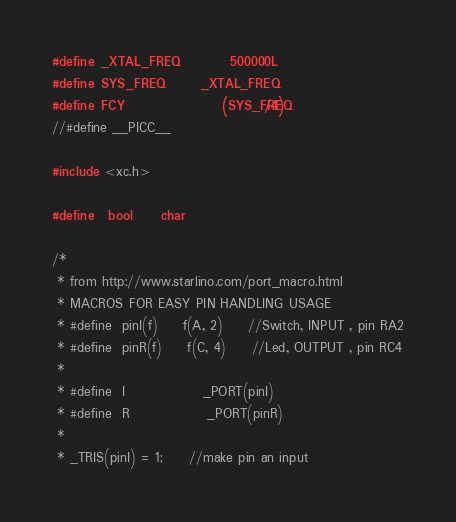<code> <loc_0><loc_0><loc_500><loc_500><_C_>#define _XTAL_FREQ		500000L
#define SYS_FREQ		_XTAL_FREQ
#define FCY				(SYS_FREQ/4)
//#define __PICC__

#include <xc.h>

#define	bool	char

/*
 * from http://www.starlino.com/port_macro.html
 * MACROS FOR EASY PIN HANDLING USAGE
 * #define	pinI(f)		f(A, 2)		//Switch, INPUT , pin RA2
 * #define	pinR(f)		f(C, 4)		//Led, OUTPUT , pin RC4
 *
 * #define	I				_PORT(pinI)
 * #define	R				_PORT(pinR)
 *
 * _TRIS(pinI) = 1;		//make pin an input</code> 